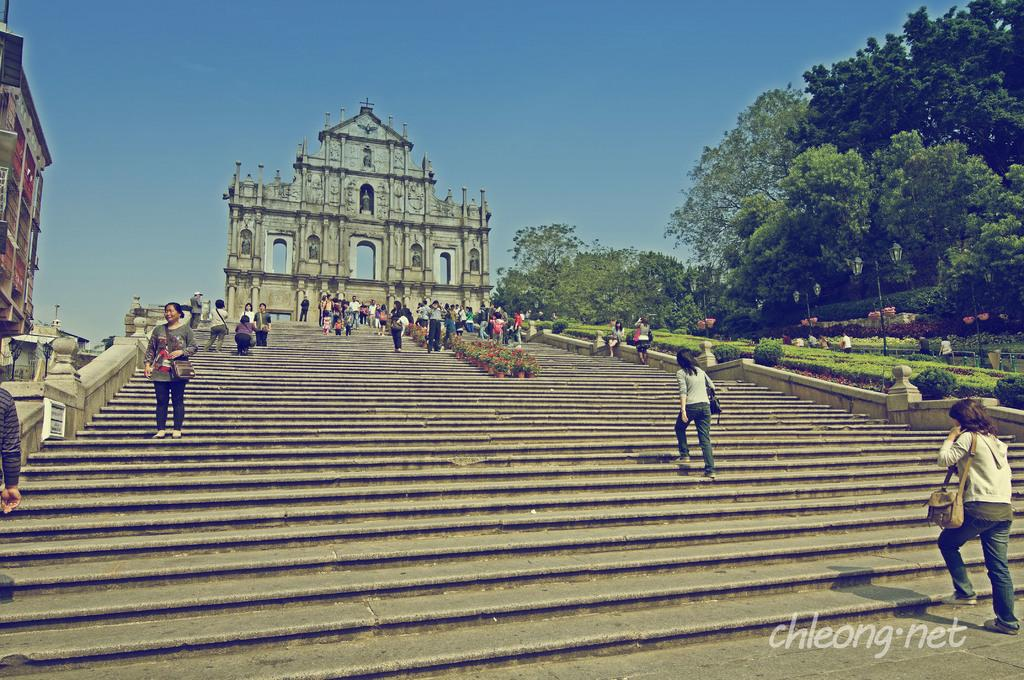What is the main structure in the image? There is a monument in the image. What is located in front of the monument? There are steps in front of the monument. How many people are visible in front of the monument? There are many people in front of the monument. What type of vegetation can be seen on the right side of the image? There are plenty of trees on the right side of the image. What type of shoes are the people wearing in the image? There is no information about the shoes the people are wearing in the image. --- Facts: 1. There is a car in the image. 2. The car is red. 3. The car has four wheels. 4. There is a road in the image. 5. The road is paved. Absurd Topics: ocean, bird, umbrella Conversation: What is the main subject in the image? There is a car in the image. What color is the car? The car is red. How many wheels does the car have? The car has four wheels. What type of surface is visible in the image? There is a road in the image, and it is paved. Reasoning: Let's think step by step in order to produce the conversation. We start by identifying the main subject in the image, which is the car. Then, we expand the conversation to include other details about the car, such as its color and the number of wheels. Finally, we describe the road in the image, noting that it is paved. Each question is designed to elicit a specific detail about the image that is known from the provided facts. Absurd Question/Answer: Can you see any ocean waves in the image? There is no ocean or waves present in the image; it features a red car on a paved road. 